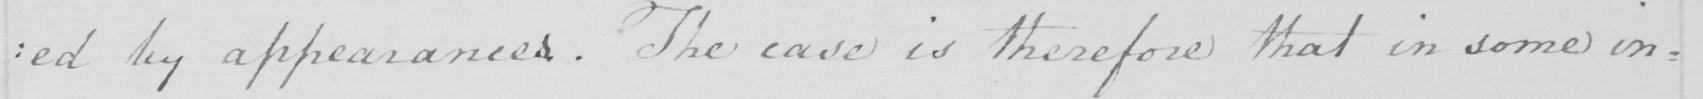Please transcribe the handwritten text in this image. : ed by appearances . The case is therefore that in some in : 